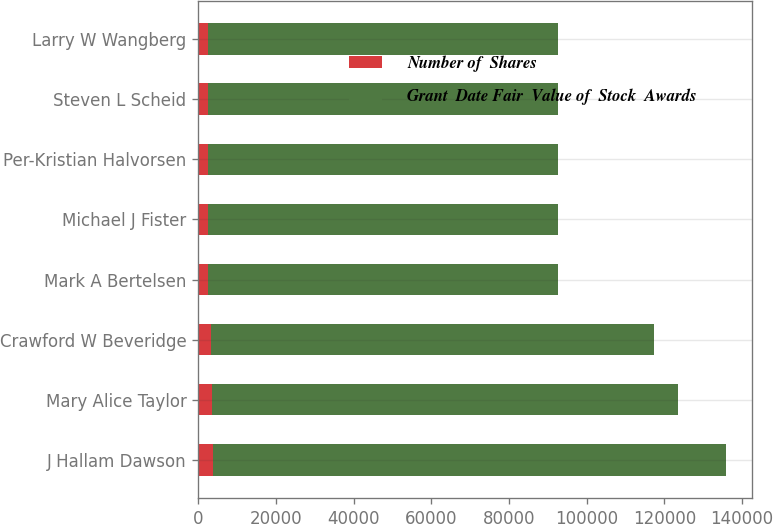Convert chart. <chart><loc_0><loc_0><loc_500><loc_500><stacked_bar_chart><ecel><fcel>J Hallam Dawson<fcel>Mary Alice Taylor<fcel>Crawford W Beveridge<fcel>Mark A Bertelsen<fcel>Michael J Fister<fcel>Per-Kristian Halvorsen<fcel>Steven L Scheid<fcel>Larry W Wangberg<nl><fcel>Number of  Shares<fcel>3837<fcel>3488<fcel>3314<fcel>2616<fcel>2616<fcel>2616<fcel>2616<fcel>2616<nl><fcel>Grant  Date Fair  Value of  Stock  Awards<fcel>131954<fcel>119952<fcel>113968<fcel>89964<fcel>89964<fcel>89964<fcel>89964<fcel>89964<nl></chart> 